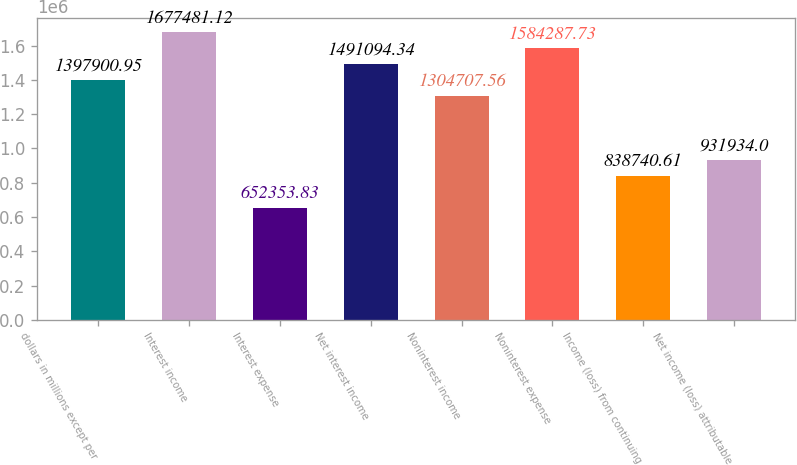Convert chart to OTSL. <chart><loc_0><loc_0><loc_500><loc_500><bar_chart><fcel>dollars in millions except per<fcel>Interest income<fcel>Interest expense<fcel>Net interest income<fcel>Noninterest income<fcel>Noninterest expense<fcel>Income (loss) from continuing<fcel>Net income (loss) attributable<nl><fcel>1.3979e+06<fcel>1.67748e+06<fcel>652354<fcel>1.49109e+06<fcel>1.30471e+06<fcel>1.58429e+06<fcel>838741<fcel>931934<nl></chart> 